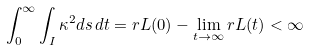<formula> <loc_0><loc_0><loc_500><loc_500>\int _ { 0 } ^ { \infty } \int _ { I } \kappa ^ { 2 } d s \, d t = r L ( 0 ) - \lim _ { t \to \infty } r L ( t ) < \infty</formula> 